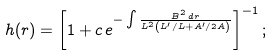Convert formula to latex. <formula><loc_0><loc_0><loc_500><loc_500>h ( r ) = \left [ 1 + c \, e ^ { - \int { \frac { B ^ { 2 } \, d r } { L ^ { 2 } \left ( L ^ { \prime } / L + A ^ { \prime } / 2 A \right ) } } } \right ] ^ { - 1 } ;</formula> 